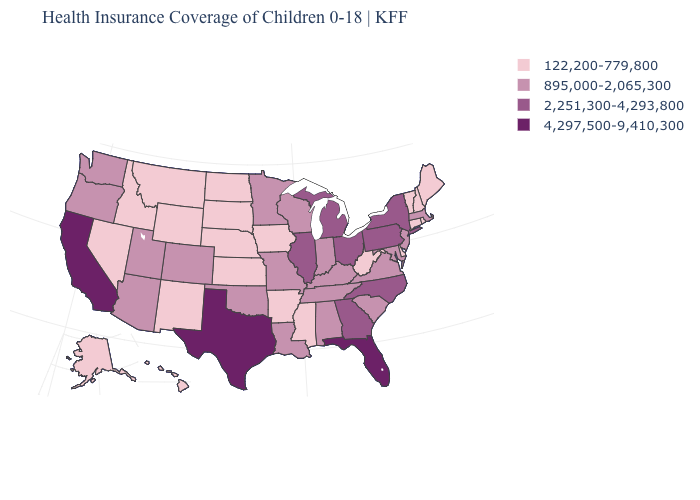Which states have the lowest value in the USA?
Write a very short answer. Alaska, Arkansas, Connecticut, Delaware, Hawaii, Idaho, Iowa, Kansas, Maine, Mississippi, Montana, Nebraska, Nevada, New Hampshire, New Mexico, North Dakota, Rhode Island, South Dakota, Vermont, West Virginia, Wyoming. Is the legend a continuous bar?
Answer briefly. No. Which states have the lowest value in the USA?
Be succinct. Alaska, Arkansas, Connecticut, Delaware, Hawaii, Idaho, Iowa, Kansas, Maine, Mississippi, Montana, Nebraska, Nevada, New Hampshire, New Mexico, North Dakota, Rhode Island, South Dakota, Vermont, West Virginia, Wyoming. Does Georgia have a lower value than California?
Short answer required. Yes. Which states hav the highest value in the Northeast?
Give a very brief answer. New York, Pennsylvania. Does Kentucky have the highest value in the USA?
Give a very brief answer. No. What is the highest value in the Northeast ?
Give a very brief answer. 2,251,300-4,293,800. Name the states that have a value in the range 895,000-2,065,300?
Keep it brief. Alabama, Arizona, Colorado, Indiana, Kentucky, Louisiana, Maryland, Massachusetts, Minnesota, Missouri, New Jersey, Oklahoma, Oregon, South Carolina, Tennessee, Utah, Virginia, Washington, Wisconsin. What is the lowest value in the Northeast?
Give a very brief answer. 122,200-779,800. Name the states that have a value in the range 122,200-779,800?
Keep it brief. Alaska, Arkansas, Connecticut, Delaware, Hawaii, Idaho, Iowa, Kansas, Maine, Mississippi, Montana, Nebraska, Nevada, New Hampshire, New Mexico, North Dakota, Rhode Island, South Dakota, Vermont, West Virginia, Wyoming. Name the states that have a value in the range 895,000-2,065,300?
Give a very brief answer. Alabama, Arizona, Colorado, Indiana, Kentucky, Louisiana, Maryland, Massachusetts, Minnesota, Missouri, New Jersey, Oklahoma, Oregon, South Carolina, Tennessee, Utah, Virginia, Washington, Wisconsin. Does the map have missing data?
Quick response, please. No. Name the states that have a value in the range 122,200-779,800?
Keep it brief. Alaska, Arkansas, Connecticut, Delaware, Hawaii, Idaho, Iowa, Kansas, Maine, Mississippi, Montana, Nebraska, Nevada, New Hampshire, New Mexico, North Dakota, Rhode Island, South Dakota, Vermont, West Virginia, Wyoming. What is the value of North Carolina?
Concise answer only. 2,251,300-4,293,800. What is the value of Iowa?
Keep it brief. 122,200-779,800. 